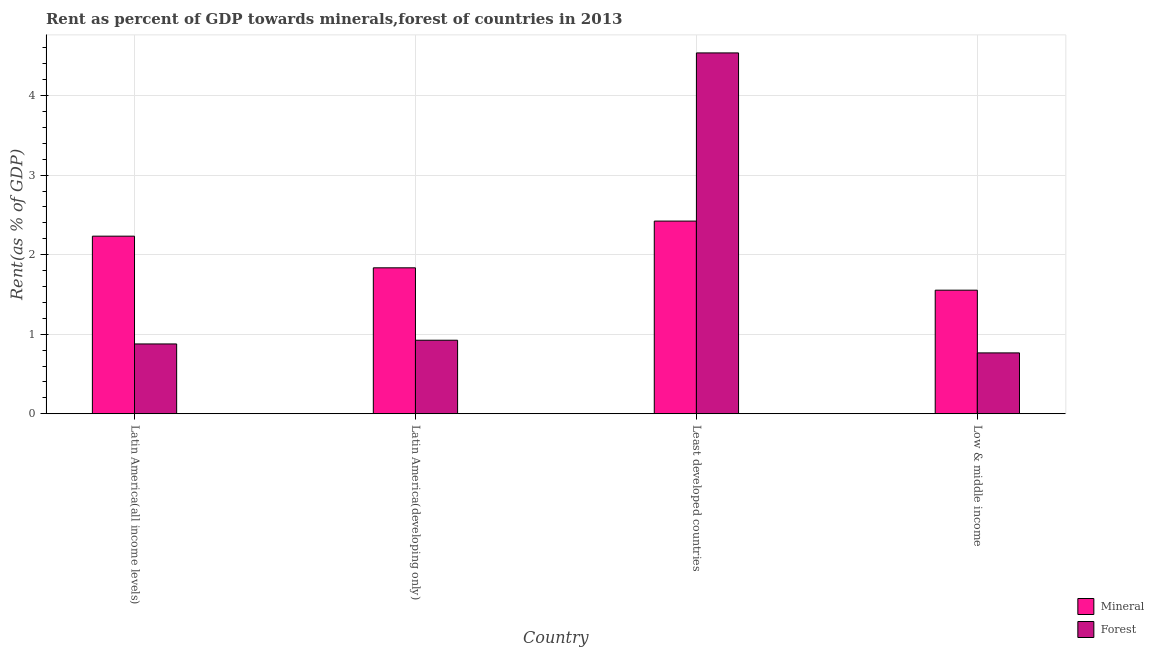How many different coloured bars are there?
Offer a very short reply. 2. How many groups of bars are there?
Offer a very short reply. 4. Are the number of bars on each tick of the X-axis equal?
Provide a short and direct response. Yes. How many bars are there on the 1st tick from the left?
Your response must be concise. 2. What is the label of the 3rd group of bars from the left?
Offer a terse response. Least developed countries. What is the mineral rent in Latin America(developing only)?
Your response must be concise. 1.83. Across all countries, what is the maximum mineral rent?
Your response must be concise. 2.42. Across all countries, what is the minimum mineral rent?
Your answer should be compact. 1.55. In which country was the forest rent maximum?
Offer a terse response. Least developed countries. In which country was the mineral rent minimum?
Offer a terse response. Low & middle income. What is the total mineral rent in the graph?
Give a very brief answer. 8.04. What is the difference between the forest rent in Latin America(developing only) and that in Least developed countries?
Provide a short and direct response. -3.61. What is the difference between the mineral rent in Latin America(all income levels) and the forest rent in Low & middle income?
Give a very brief answer. 1.47. What is the average forest rent per country?
Keep it short and to the point. 1.78. What is the difference between the mineral rent and forest rent in Latin America(developing only)?
Your answer should be very brief. 0.91. What is the ratio of the mineral rent in Latin America(all income levels) to that in Low & middle income?
Make the answer very short. 1.44. What is the difference between the highest and the second highest forest rent?
Provide a succinct answer. 3.61. What is the difference between the highest and the lowest mineral rent?
Keep it short and to the point. 0.87. In how many countries, is the forest rent greater than the average forest rent taken over all countries?
Give a very brief answer. 1. What does the 1st bar from the left in Least developed countries represents?
Your answer should be very brief. Mineral. What does the 1st bar from the right in Least developed countries represents?
Provide a succinct answer. Forest. How many bars are there?
Keep it short and to the point. 8. How many countries are there in the graph?
Your answer should be very brief. 4. What is the difference between two consecutive major ticks on the Y-axis?
Make the answer very short. 1. Are the values on the major ticks of Y-axis written in scientific E-notation?
Offer a very short reply. No. How many legend labels are there?
Provide a short and direct response. 2. How are the legend labels stacked?
Provide a short and direct response. Vertical. What is the title of the graph?
Make the answer very short. Rent as percent of GDP towards minerals,forest of countries in 2013. Does "Net savings(excluding particulate emission damage)" appear as one of the legend labels in the graph?
Your response must be concise. No. What is the label or title of the X-axis?
Provide a short and direct response. Country. What is the label or title of the Y-axis?
Provide a succinct answer. Rent(as % of GDP). What is the Rent(as % of GDP) in Mineral in Latin America(all income levels)?
Ensure brevity in your answer.  2.23. What is the Rent(as % of GDP) in Forest in Latin America(all income levels)?
Your response must be concise. 0.88. What is the Rent(as % of GDP) in Mineral in Latin America(developing only)?
Your answer should be compact. 1.83. What is the Rent(as % of GDP) in Forest in Latin America(developing only)?
Your answer should be very brief. 0.92. What is the Rent(as % of GDP) of Mineral in Least developed countries?
Your response must be concise. 2.42. What is the Rent(as % of GDP) in Forest in Least developed countries?
Give a very brief answer. 4.54. What is the Rent(as % of GDP) in Mineral in Low & middle income?
Provide a short and direct response. 1.55. What is the Rent(as % of GDP) in Forest in Low & middle income?
Make the answer very short. 0.77. Across all countries, what is the maximum Rent(as % of GDP) of Mineral?
Keep it short and to the point. 2.42. Across all countries, what is the maximum Rent(as % of GDP) in Forest?
Provide a short and direct response. 4.54. Across all countries, what is the minimum Rent(as % of GDP) in Mineral?
Offer a terse response. 1.55. Across all countries, what is the minimum Rent(as % of GDP) of Forest?
Ensure brevity in your answer.  0.77. What is the total Rent(as % of GDP) in Mineral in the graph?
Provide a short and direct response. 8.04. What is the total Rent(as % of GDP) in Forest in the graph?
Offer a terse response. 7.1. What is the difference between the Rent(as % of GDP) in Mineral in Latin America(all income levels) and that in Latin America(developing only)?
Make the answer very short. 0.4. What is the difference between the Rent(as % of GDP) in Forest in Latin America(all income levels) and that in Latin America(developing only)?
Offer a very short reply. -0.05. What is the difference between the Rent(as % of GDP) of Mineral in Latin America(all income levels) and that in Least developed countries?
Make the answer very short. -0.19. What is the difference between the Rent(as % of GDP) of Forest in Latin America(all income levels) and that in Least developed countries?
Provide a succinct answer. -3.66. What is the difference between the Rent(as % of GDP) in Mineral in Latin America(all income levels) and that in Low & middle income?
Make the answer very short. 0.68. What is the difference between the Rent(as % of GDP) of Forest in Latin America(all income levels) and that in Low & middle income?
Provide a short and direct response. 0.11. What is the difference between the Rent(as % of GDP) of Mineral in Latin America(developing only) and that in Least developed countries?
Give a very brief answer. -0.59. What is the difference between the Rent(as % of GDP) in Forest in Latin America(developing only) and that in Least developed countries?
Make the answer very short. -3.61. What is the difference between the Rent(as % of GDP) in Mineral in Latin America(developing only) and that in Low & middle income?
Ensure brevity in your answer.  0.28. What is the difference between the Rent(as % of GDP) of Forest in Latin America(developing only) and that in Low & middle income?
Provide a short and direct response. 0.16. What is the difference between the Rent(as % of GDP) of Mineral in Least developed countries and that in Low & middle income?
Keep it short and to the point. 0.87. What is the difference between the Rent(as % of GDP) of Forest in Least developed countries and that in Low & middle income?
Offer a terse response. 3.77. What is the difference between the Rent(as % of GDP) in Mineral in Latin America(all income levels) and the Rent(as % of GDP) in Forest in Latin America(developing only)?
Provide a succinct answer. 1.31. What is the difference between the Rent(as % of GDP) of Mineral in Latin America(all income levels) and the Rent(as % of GDP) of Forest in Least developed countries?
Make the answer very short. -2.3. What is the difference between the Rent(as % of GDP) in Mineral in Latin America(all income levels) and the Rent(as % of GDP) in Forest in Low & middle income?
Your response must be concise. 1.47. What is the difference between the Rent(as % of GDP) in Mineral in Latin America(developing only) and the Rent(as % of GDP) in Forest in Least developed countries?
Give a very brief answer. -2.7. What is the difference between the Rent(as % of GDP) of Mineral in Latin America(developing only) and the Rent(as % of GDP) of Forest in Low & middle income?
Your answer should be compact. 1.07. What is the difference between the Rent(as % of GDP) of Mineral in Least developed countries and the Rent(as % of GDP) of Forest in Low & middle income?
Your answer should be very brief. 1.66. What is the average Rent(as % of GDP) in Mineral per country?
Your response must be concise. 2.01. What is the average Rent(as % of GDP) in Forest per country?
Keep it short and to the point. 1.78. What is the difference between the Rent(as % of GDP) in Mineral and Rent(as % of GDP) in Forest in Latin America(all income levels)?
Your answer should be compact. 1.36. What is the difference between the Rent(as % of GDP) in Mineral and Rent(as % of GDP) in Forest in Latin America(developing only)?
Give a very brief answer. 0.91. What is the difference between the Rent(as % of GDP) in Mineral and Rent(as % of GDP) in Forest in Least developed countries?
Provide a short and direct response. -2.11. What is the difference between the Rent(as % of GDP) of Mineral and Rent(as % of GDP) of Forest in Low & middle income?
Make the answer very short. 0.79. What is the ratio of the Rent(as % of GDP) of Mineral in Latin America(all income levels) to that in Latin America(developing only)?
Your answer should be compact. 1.22. What is the ratio of the Rent(as % of GDP) of Forest in Latin America(all income levels) to that in Latin America(developing only)?
Your response must be concise. 0.95. What is the ratio of the Rent(as % of GDP) in Mineral in Latin America(all income levels) to that in Least developed countries?
Make the answer very short. 0.92. What is the ratio of the Rent(as % of GDP) of Forest in Latin America(all income levels) to that in Least developed countries?
Keep it short and to the point. 0.19. What is the ratio of the Rent(as % of GDP) of Mineral in Latin America(all income levels) to that in Low & middle income?
Ensure brevity in your answer.  1.44. What is the ratio of the Rent(as % of GDP) in Forest in Latin America(all income levels) to that in Low & middle income?
Keep it short and to the point. 1.15. What is the ratio of the Rent(as % of GDP) of Mineral in Latin America(developing only) to that in Least developed countries?
Provide a short and direct response. 0.76. What is the ratio of the Rent(as % of GDP) in Forest in Latin America(developing only) to that in Least developed countries?
Keep it short and to the point. 0.2. What is the ratio of the Rent(as % of GDP) of Mineral in Latin America(developing only) to that in Low & middle income?
Provide a short and direct response. 1.18. What is the ratio of the Rent(as % of GDP) in Forest in Latin America(developing only) to that in Low & middle income?
Your answer should be compact. 1.21. What is the ratio of the Rent(as % of GDP) in Mineral in Least developed countries to that in Low & middle income?
Offer a very short reply. 1.56. What is the ratio of the Rent(as % of GDP) of Forest in Least developed countries to that in Low & middle income?
Provide a succinct answer. 5.93. What is the difference between the highest and the second highest Rent(as % of GDP) in Mineral?
Ensure brevity in your answer.  0.19. What is the difference between the highest and the second highest Rent(as % of GDP) of Forest?
Ensure brevity in your answer.  3.61. What is the difference between the highest and the lowest Rent(as % of GDP) in Mineral?
Offer a very short reply. 0.87. What is the difference between the highest and the lowest Rent(as % of GDP) of Forest?
Offer a very short reply. 3.77. 